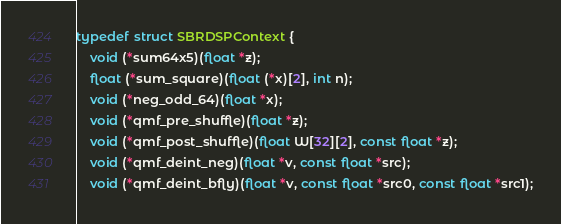Convert code to text. <code><loc_0><loc_0><loc_500><loc_500><_C_>typedef struct SBRDSPContext {
    void (*sum64x5)(float *z);
    float (*sum_square)(float (*x)[2], int n);
    void (*neg_odd_64)(float *x);
    void (*qmf_pre_shuffle)(float *z);
    void (*qmf_post_shuffle)(float W[32][2], const float *z);
    void (*qmf_deint_neg)(float *v, const float *src);
    void (*qmf_deint_bfly)(float *v, const float *src0, const float *src1);</code> 